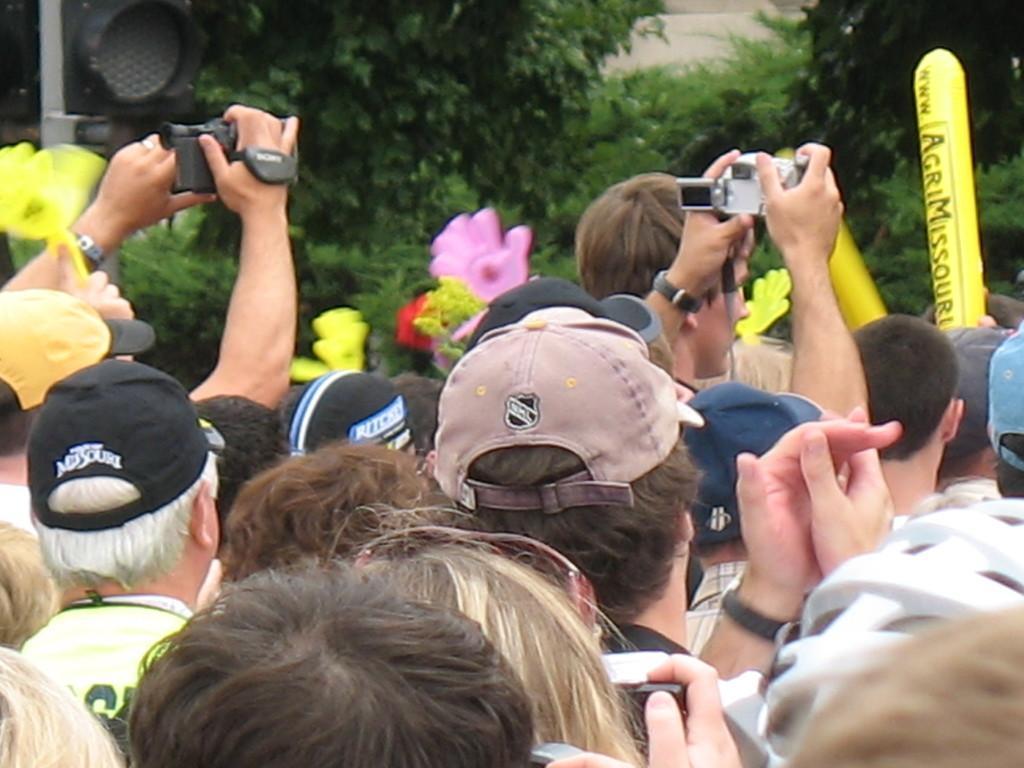Could you give a brief overview of what you see in this image? In this image we can see a group of persons are standing, and holding a camera in the hands, there is the traffic signal, there are the trees. 